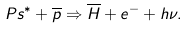Convert formula to latex. <formula><loc_0><loc_0><loc_500><loc_500>P s ^ { * } + \overline { p } \Rightarrow \overline { H } + e ^ { - } + h \nu .</formula> 